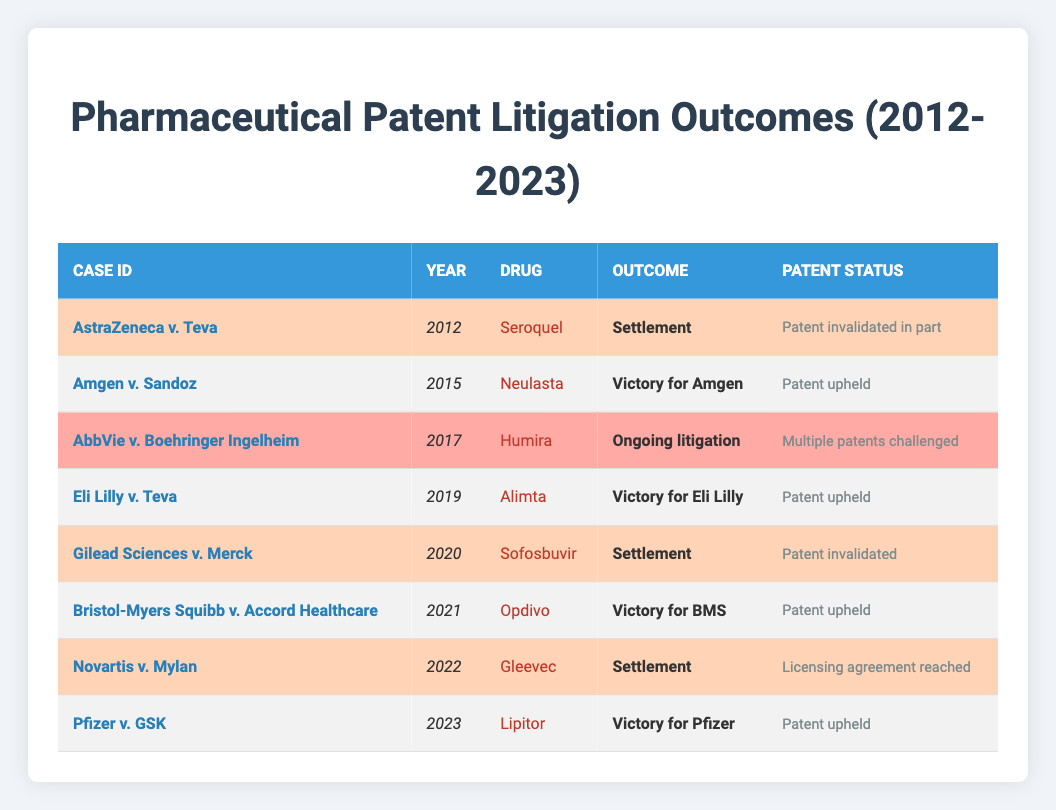What was the outcome of the case AstraZeneca v. Teva? The table shows that the outcome of the case AstraZeneca v. Teva in 2012 was a settlement.
Answer: Settlement Which drug was involved in the case with a victory for Eli Lilly? The table indicates that the drug involved in the case with a victory for Eli Lilly in 2019 was Alimta.
Answer: Alimta How many cases resulted in a settlement from 2012 to 2023? The table lists three cases with a settlement outcome: AstraZeneca v. Teva, Gilead Sciences v. Merck, and Novartis v. Mylan, making it a total of three.
Answer: 3 Was there any case in which multiple patents were challenged? The table shows that the case AbbVie v. Boehringer Ingelheim involved multiple patents challenged, confirming that such a case existed.
Answer: Yes What is the total number of victories for pharmaceutical companies listed in the table? The table shows five cases with victories: Amgen v. Sandoz, Eli Lilly v. Teva, Bristol-Myers Squibb v. Accord Healthcare, and Pfizer v. GSK. Thus, there are four victories for pharmaceutical companies.
Answer: 4 In which year did the case involving Gleevec occur? According to the table, the case involving Gleevec, Novartis v. Mylan, occurred in 2022.
Answer: 2022 What was the patent status in the case of Pfizer v. GSK? The table indicates that the patent status for the case Pfizer v. GSK in 2023 was "Patent upheld."
Answer: Patent upheld Which case had an ongoing litigation status and what was the drug involved? The table specifies that the case AbbVie v. Boehringer Ingelheim had an ongoing litigation status and the drug involved was Humira.
Answer: AbbVie v. Boehringer Ingelheim - Humira How many years passed between the first case and the last case in the table? The first case listed is from 2012 and the last case from 2023. The difference in years is 2023 - 2012 = 11 years.
Answer: 11 years What was the patent status of the case involving Sofosbuvir? In the table, it is stated that in the case Gilead Sciences v. Merck, the patent status for Sofosbuvir was "Patent invalidated."
Answer: Patent invalidated 